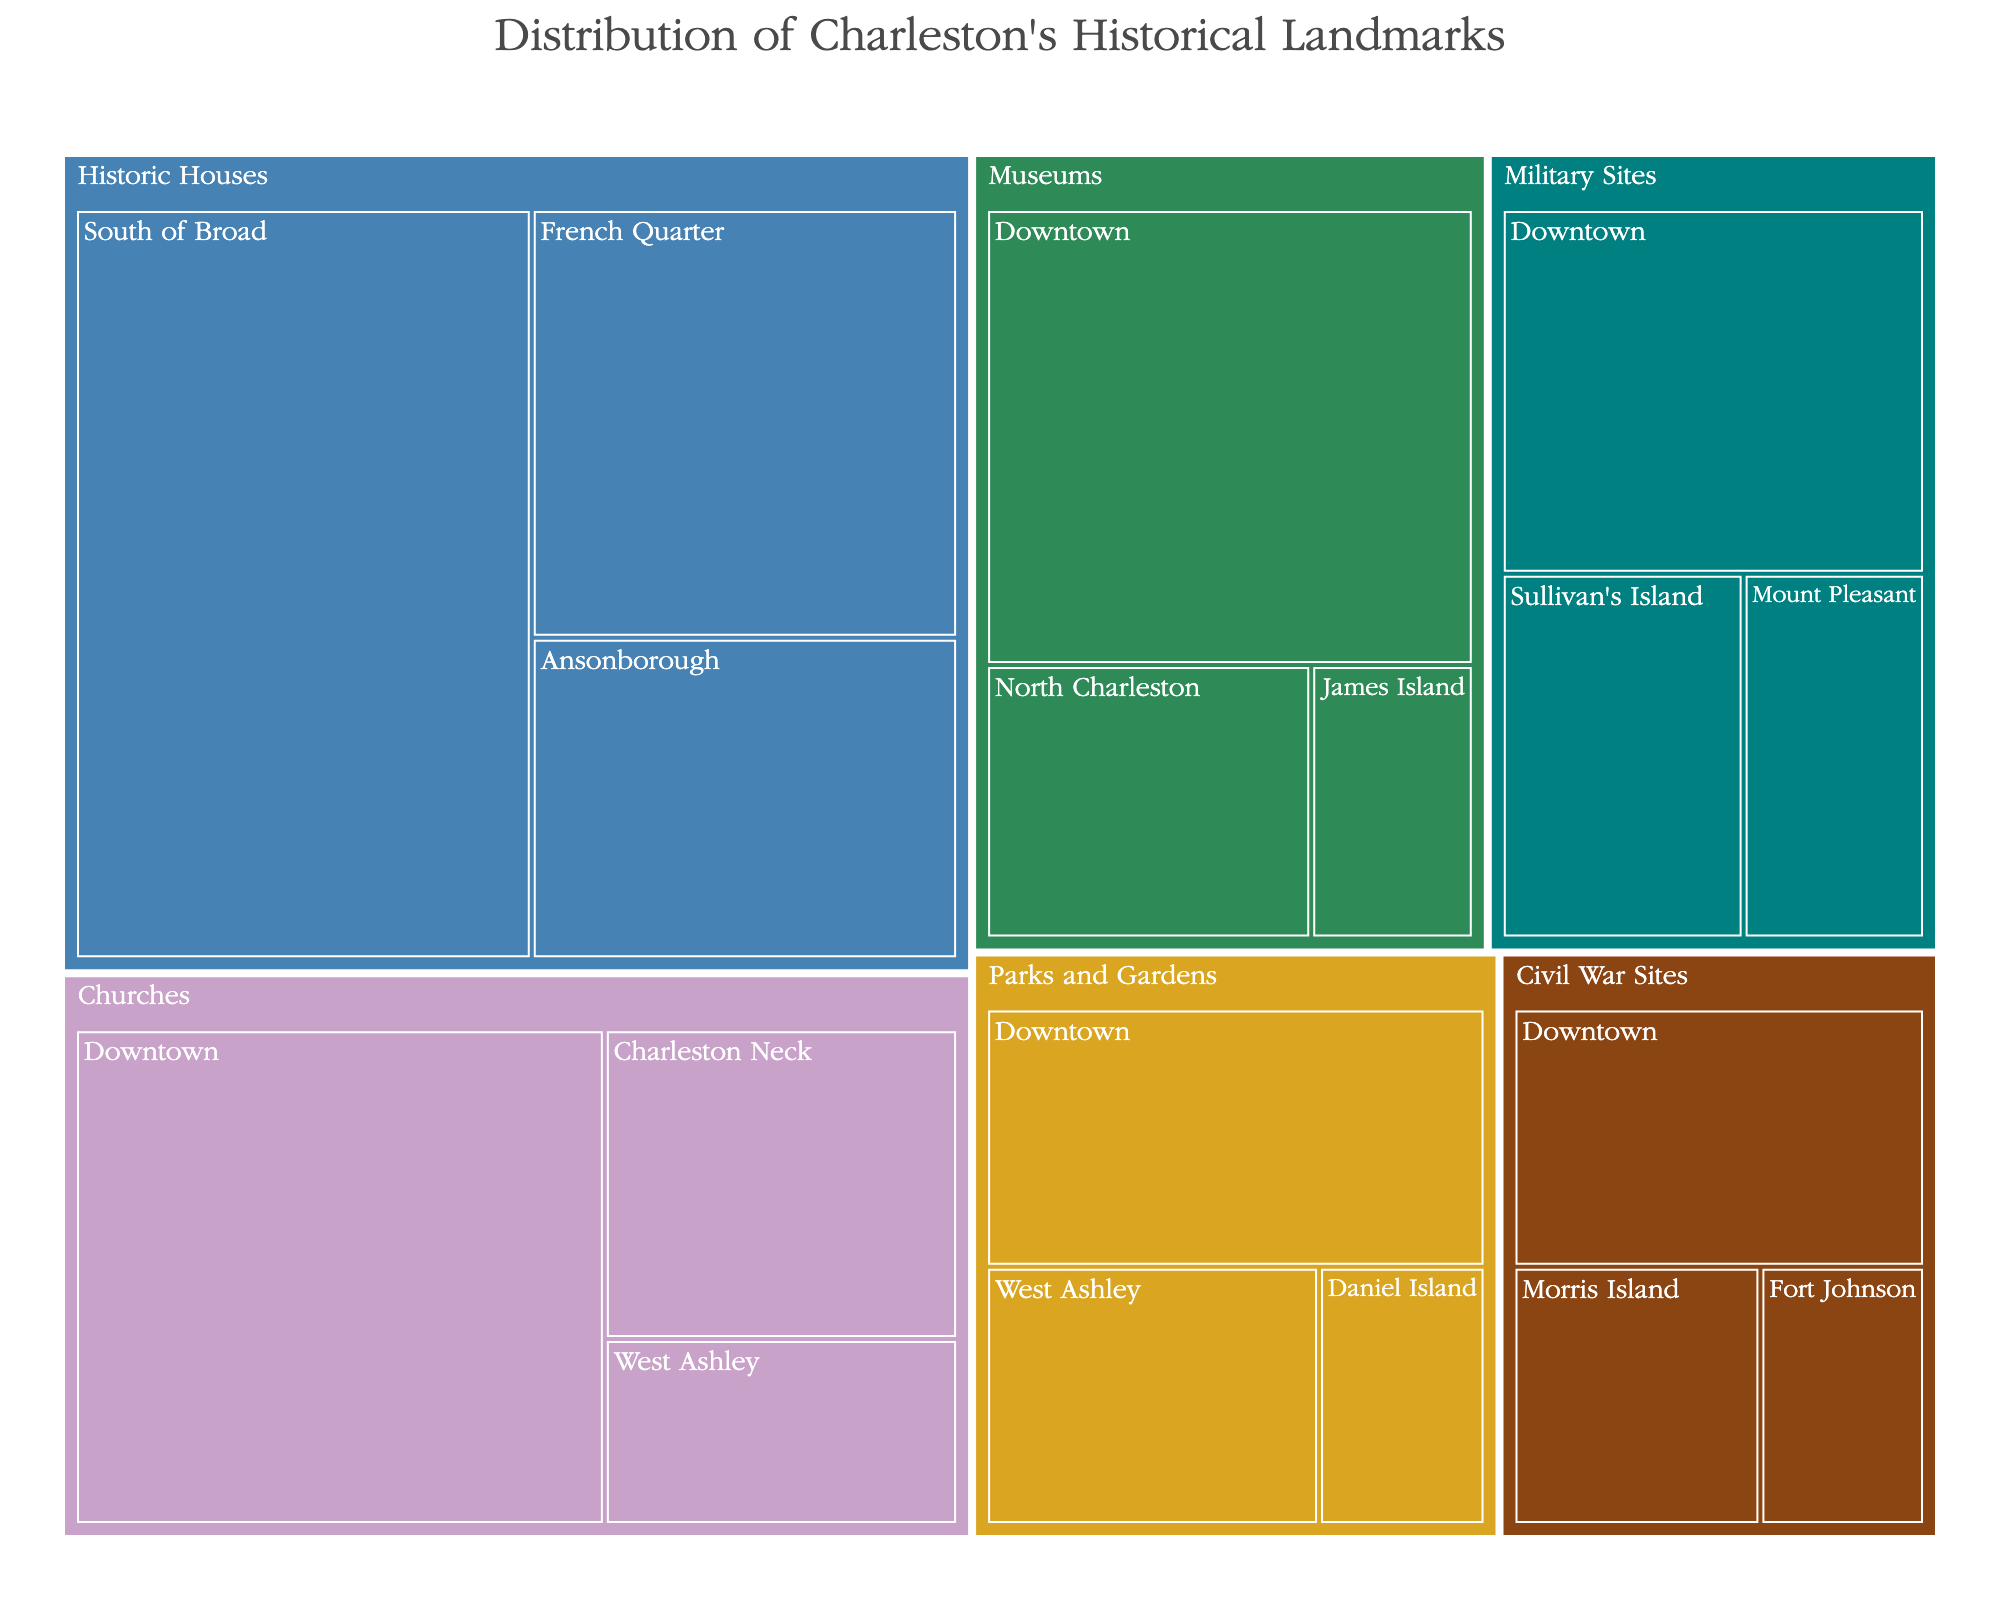Which category has the largest number of historical landmarks? The largest block in the treemap indicates the category with the most historical landmarks, which is the "Historic Houses" category.
Answer: Historic Houses How many landmarks are there in the "Downtown" subcategory in total? Summing up the values for all subcategories under "Downtown": Churches (12) + Military Sites (7) + Museums (10) + Parks and Gardens (6) + Civil War Sites (5) = 40.
Answer: 40 Which subcategory of "Military Sites" has the fewest landmarks? The smallest block under "Military Sites" indicates the subcategory with the fewest landmarks, which is "Mount Pleasant".
Answer: Mount Pleasant What is the combined total of landmarks for "Churches" and "Museums"? Adding the total values for "Churches" (12 + 5 + 3 = 20) and "Museums" (10 + 4 + 2 = 16) gives us 20 + 16 = 36.
Answer: 36 Are there more "Parks and Gardens" landmarks in "Downtown" or "West Ashley"? Comparing the values, "Parks and Gardens" in Downtown (6) is greater than in West Ashley (4).
Answer: Downtown How many more landmarks are there in "South of Broad" compared to "Charleston Neck"? The value in "South of Broad" is 15, and "Charleston Neck" is 5, so the difference is 15 - 5 = 10.
Answer: 10 What is the least represented category in terms of landmarks? The smallest blocks for each category collectively indicate that "Civil War Sites" has the fewest total landmarks (5 + 3 + 2 = 10).
Answer: Civil War Sites Which category has landmarks in the most different locations? The count of unique subcategories shown for each main category in the treemap indicates that "Churches" are present in Downtown, Charleston Neck, and West Ashley, totaling 3 locations.
Answer: Churches 